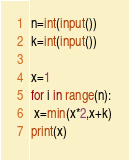<code> <loc_0><loc_0><loc_500><loc_500><_Python_>n=int(input())
k=int(input())

x=1
for i in range(n):
 x=min(x*2,x+k)
print(x)</code> 